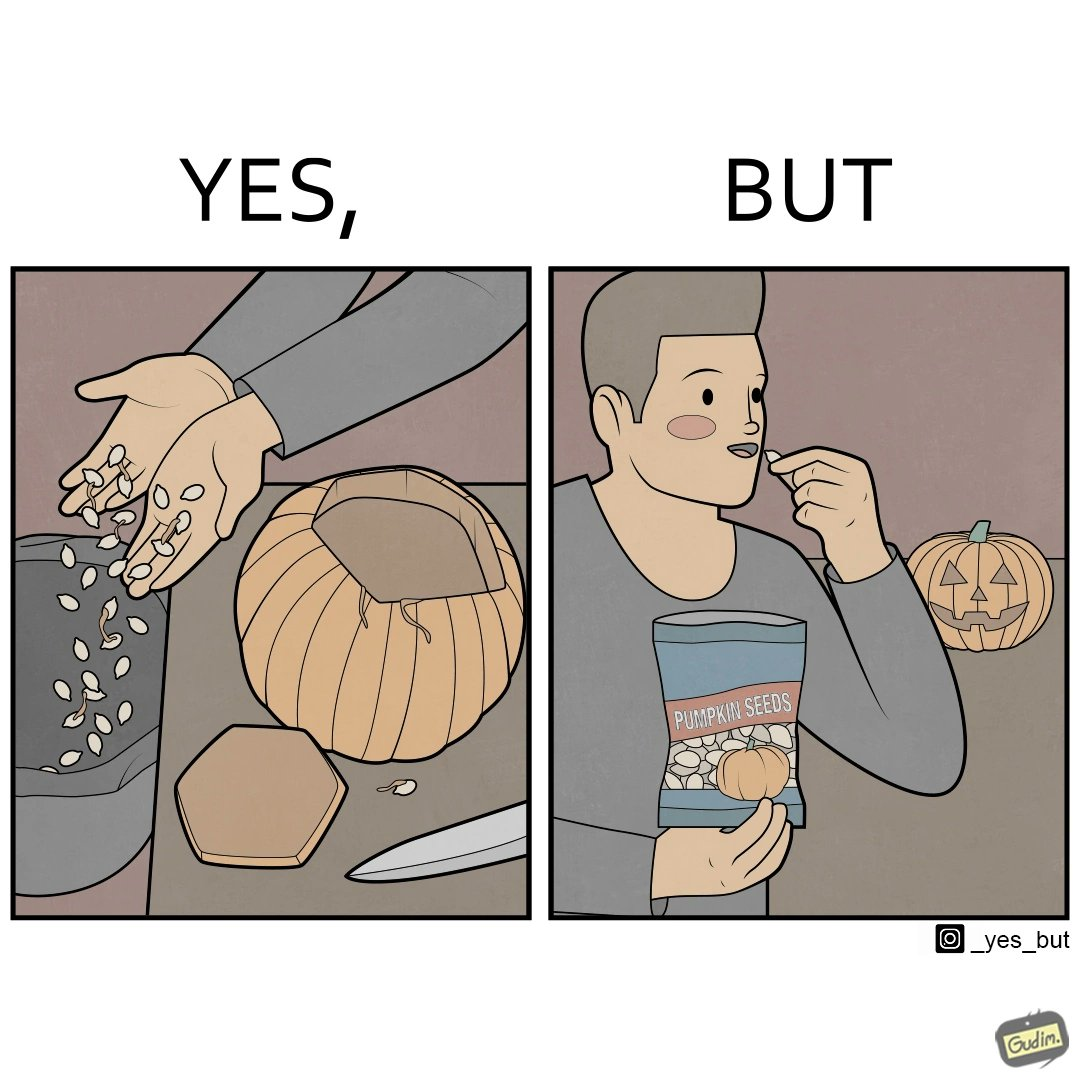What is shown in the left half versus the right half of this image? In the left part of the image: a person removing seeds from the pumpkin In the right part of the image: a person eating packaged pumpkin seeds having a pumpkin carved in the shape of a jack-o'-lantern, used in halloween 